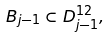Convert formula to latex. <formula><loc_0><loc_0><loc_500><loc_500>B _ { j - 1 } \subset D _ { j - 1 } ^ { 1 2 } ,</formula> 